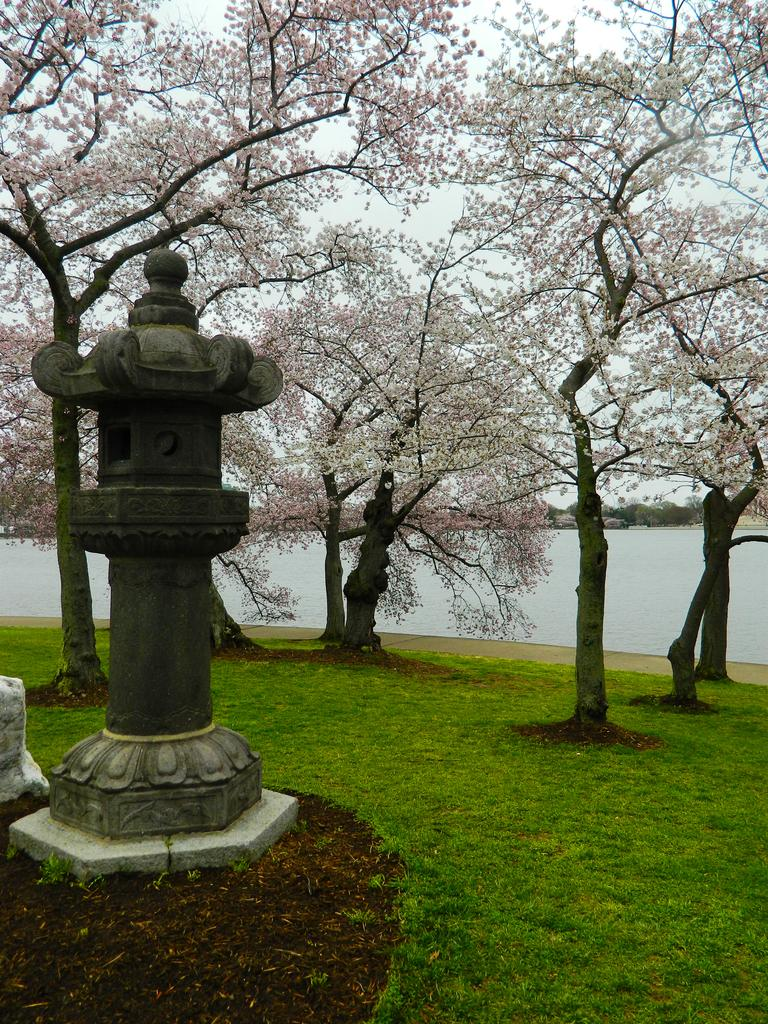What type of vegetation can be seen in the image? There are trees in the image. What is at the bottom of the image? There is grass at the bottom of the image. What natural element is visible in the image? There is water visible in the image. What type of structure can be seen on the left side of the image? There is a stone structure on the left side of the image. How many pairs of shoes are visible in the image? There are no shoes present in the image. What emotion can be seen on the trees in the image? Trees do not have emotions, so this cannot be determined from the image. 